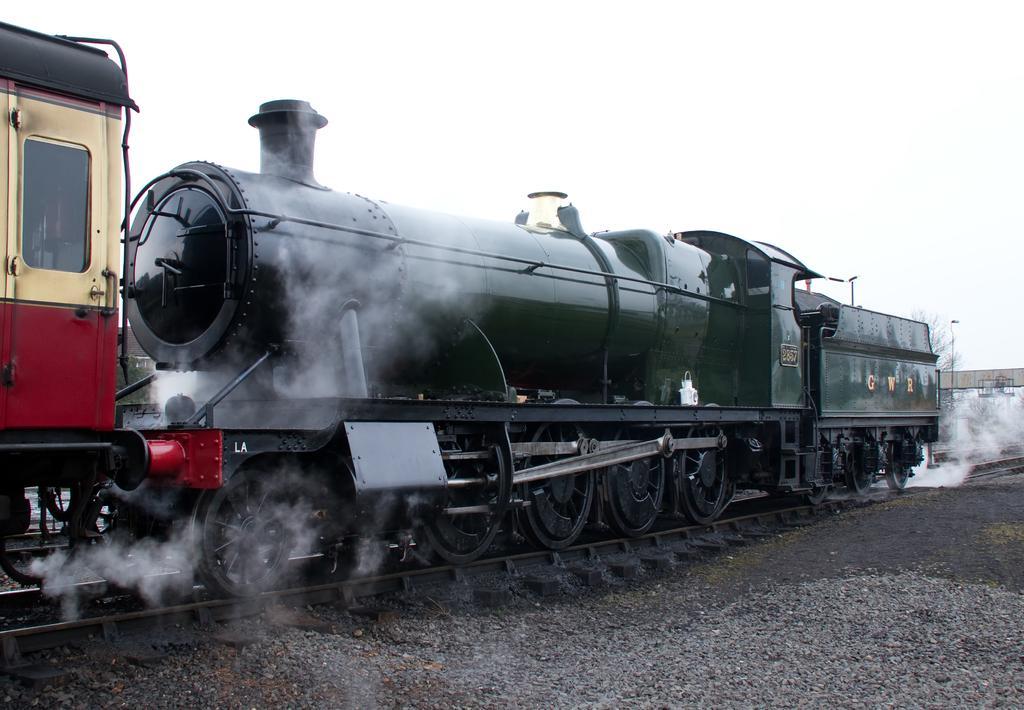Please provide a concise description of this image. In this picture we can see a steam engine on the railway track. On the right side of the steam engine there are some objects, a tree and the sky. In front of the steam engine there are stones. 